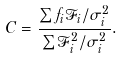Convert formula to latex. <formula><loc_0><loc_0><loc_500><loc_500>C = \frac { \sum f _ { i } \mathcal { F } _ { i } / \sigma _ { i } ^ { 2 } } { \sum \mathcal { F } _ { i } ^ { 2 } / \sigma _ { i } ^ { 2 } } .</formula> 